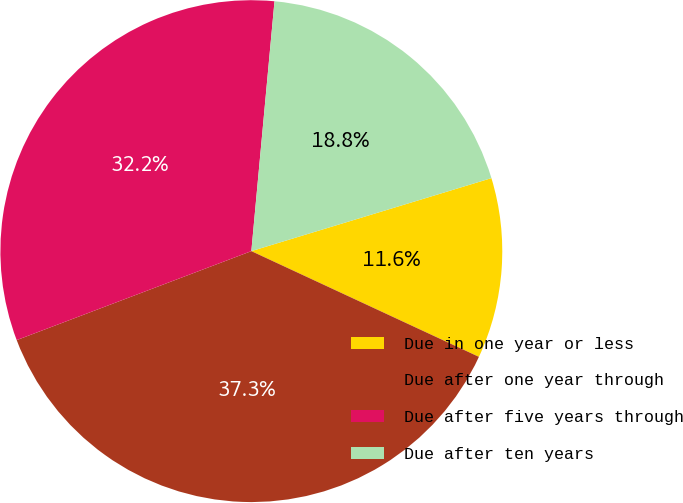Convert chart. <chart><loc_0><loc_0><loc_500><loc_500><pie_chart><fcel>Due in one year or less<fcel>Due after one year through<fcel>Due after five years through<fcel>Due after ten years<nl><fcel>11.62%<fcel>37.31%<fcel>32.24%<fcel>18.83%<nl></chart> 